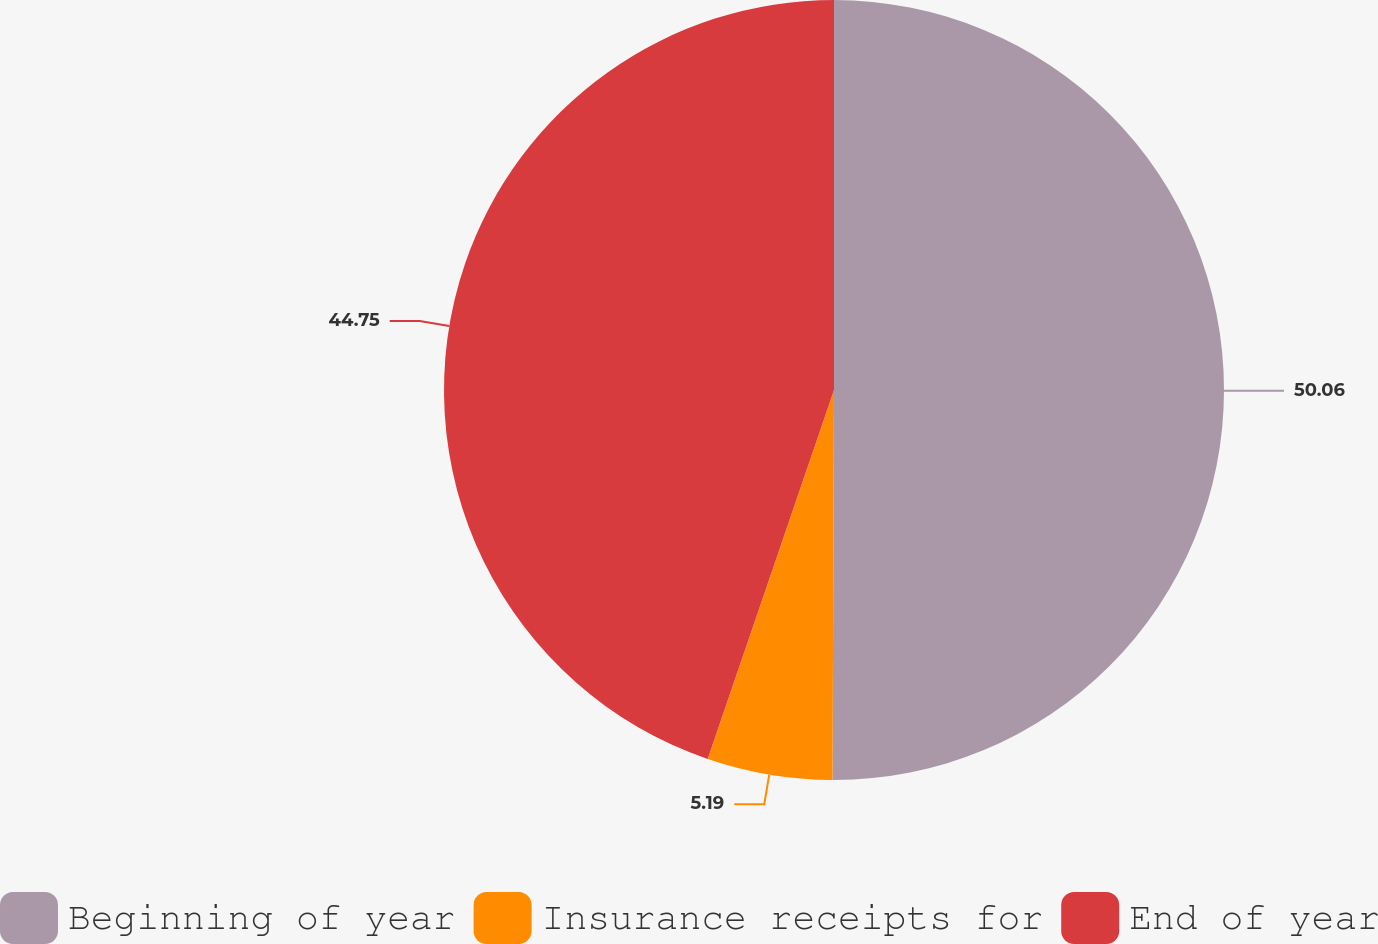Convert chart. <chart><loc_0><loc_0><loc_500><loc_500><pie_chart><fcel>Beginning of year<fcel>Insurance receipts for<fcel>End of year<nl><fcel>50.06%<fcel>5.19%<fcel>44.75%<nl></chart> 